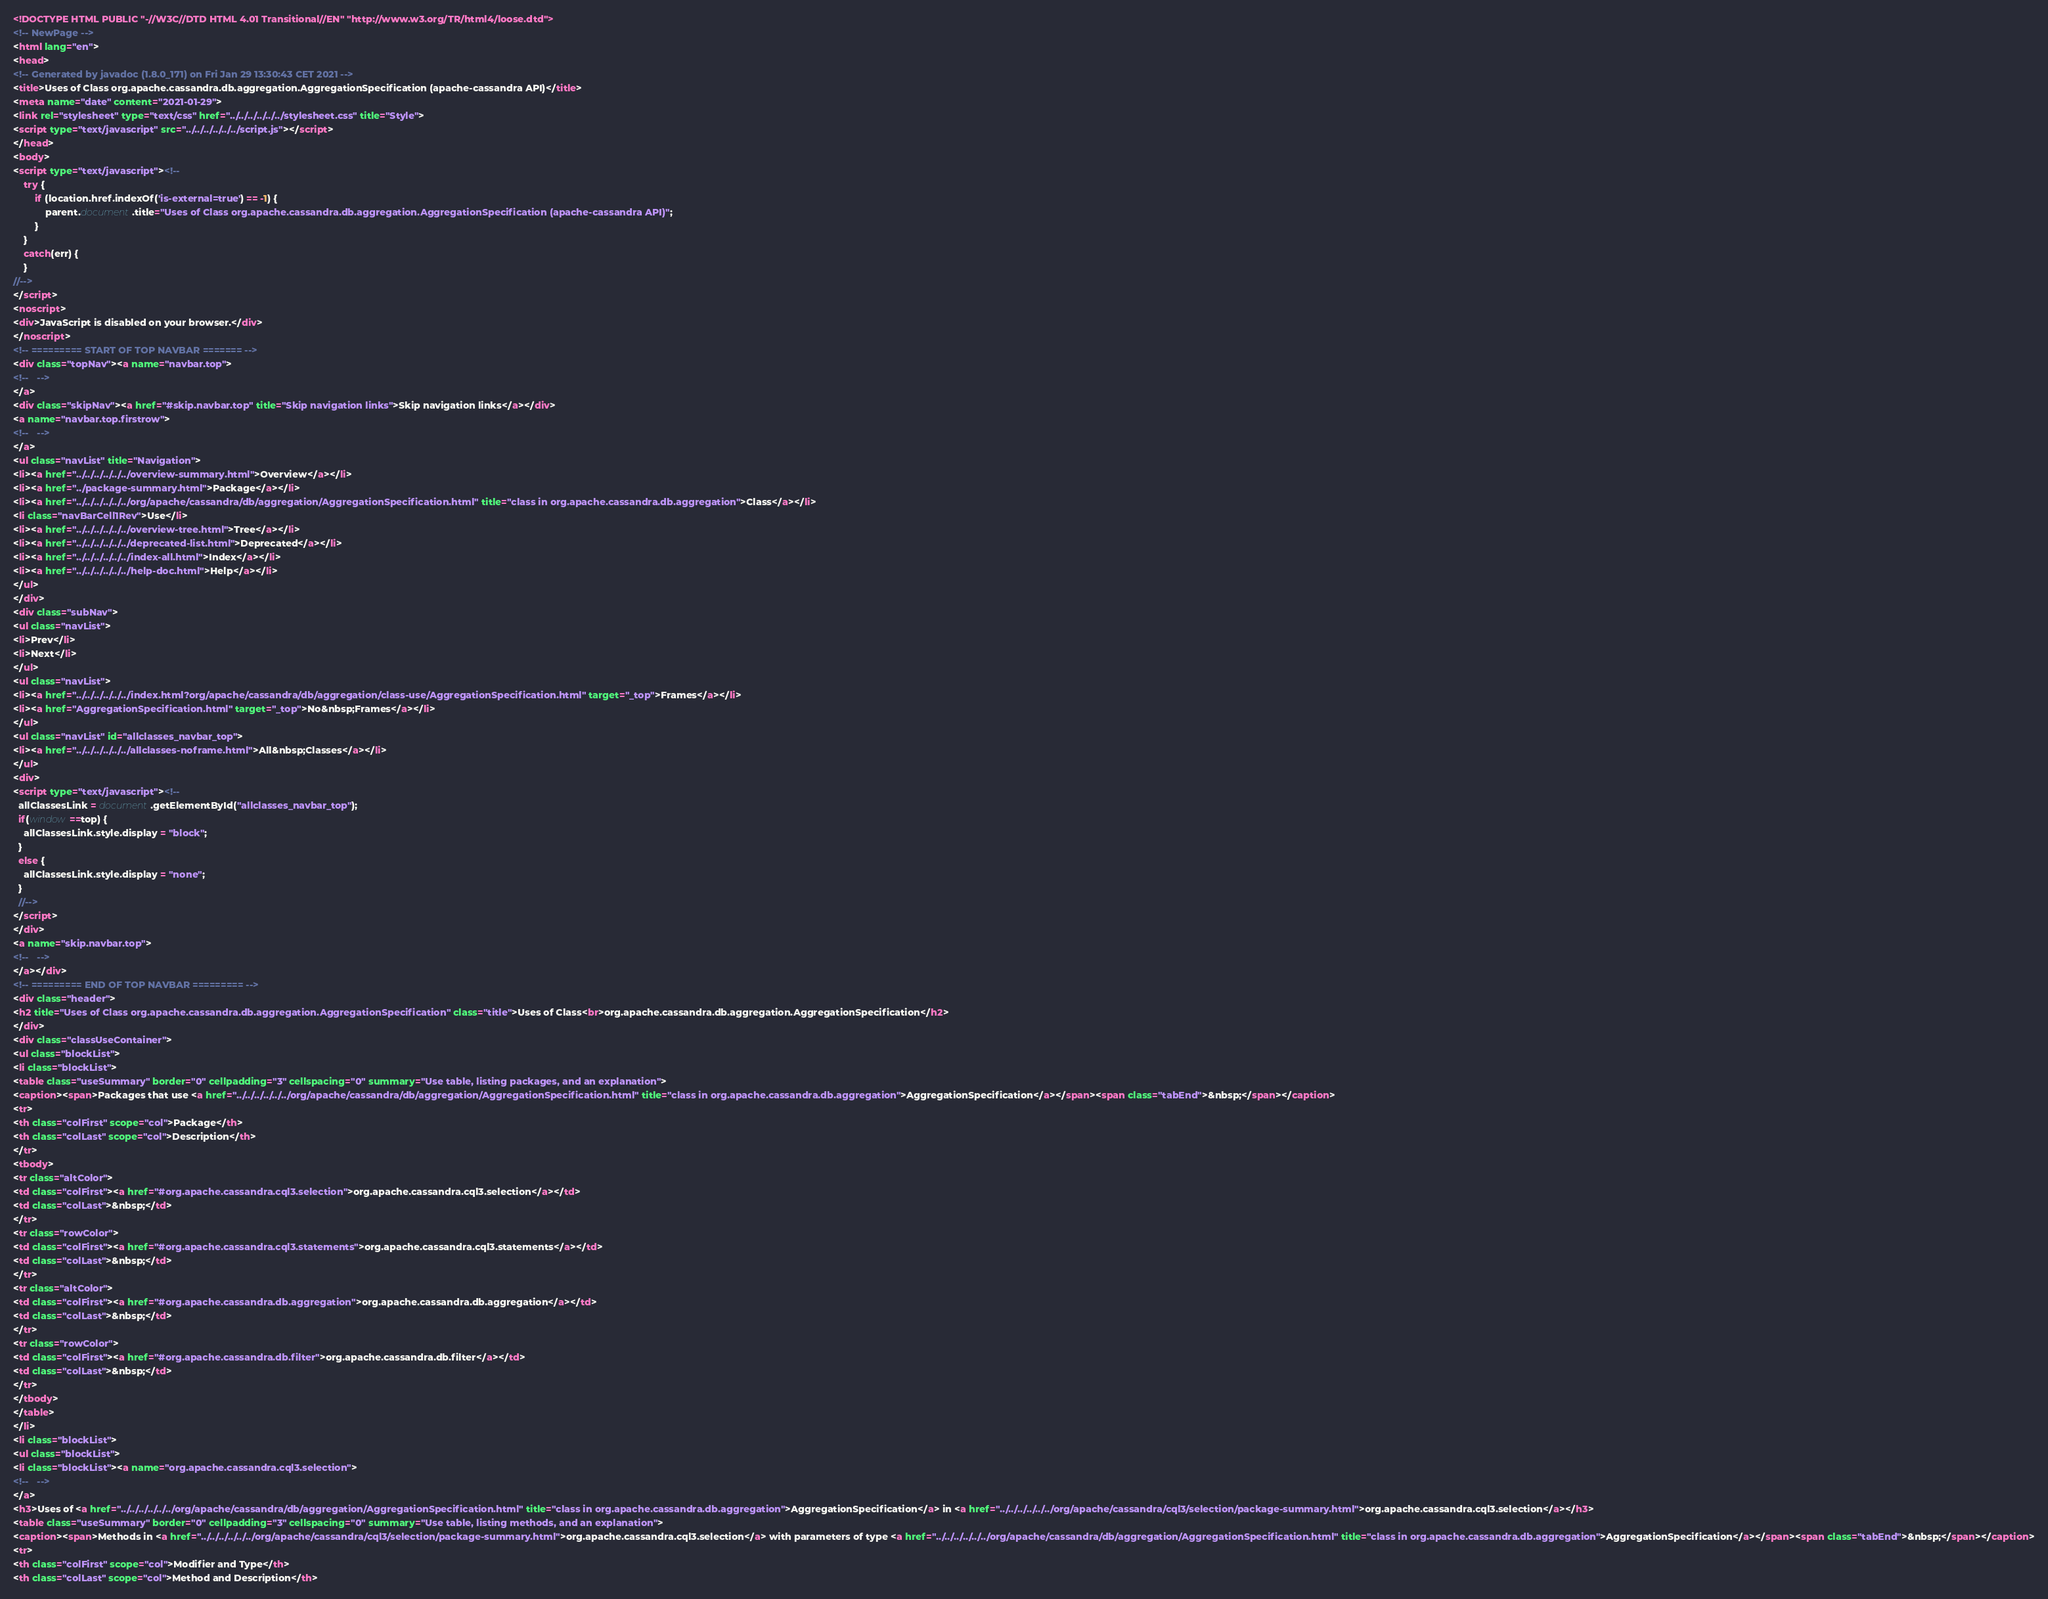Convert code to text. <code><loc_0><loc_0><loc_500><loc_500><_HTML_><!DOCTYPE HTML PUBLIC "-//W3C//DTD HTML 4.01 Transitional//EN" "http://www.w3.org/TR/html4/loose.dtd">
<!-- NewPage -->
<html lang="en">
<head>
<!-- Generated by javadoc (1.8.0_171) on Fri Jan 29 13:30:43 CET 2021 -->
<title>Uses of Class org.apache.cassandra.db.aggregation.AggregationSpecification (apache-cassandra API)</title>
<meta name="date" content="2021-01-29">
<link rel="stylesheet" type="text/css" href="../../../../../../stylesheet.css" title="Style">
<script type="text/javascript" src="../../../../../../script.js"></script>
</head>
<body>
<script type="text/javascript"><!--
    try {
        if (location.href.indexOf('is-external=true') == -1) {
            parent.document.title="Uses of Class org.apache.cassandra.db.aggregation.AggregationSpecification (apache-cassandra API)";
        }
    }
    catch(err) {
    }
//-->
</script>
<noscript>
<div>JavaScript is disabled on your browser.</div>
</noscript>
<!-- ========= START OF TOP NAVBAR ======= -->
<div class="topNav"><a name="navbar.top">
<!--   -->
</a>
<div class="skipNav"><a href="#skip.navbar.top" title="Skip navigation links">Skip navigation links</a></div>
<a name="navbar.top.firstrow">
<!--   -->
</a>
<ul class="navList" title="Navigation">
<li><a href="../../../../../../overview-summary.html">Overview</a></li>
<li><a href="../package-summary.html">Package</a></li>
<li><a href="../../../../../../org/apache/cassandra/db/aggregation/AggregationSpecification.html" title="class in org.apache.cassandra.db.aggregation">Class</a></li>
<li class="navBarCell1Rev">Use</li>
<li><a href="../../../../../../overview-tree.html">Tree</a></li>
<li><a href="../../../../../../deprecated-list.html">Deprecated</a></li>
<li><a href="../../../../../../index-all.html">Index</a></li>
<li><a href="../../../../../../help-doc.html">Help</a></li>
</ul>
</div>
<div class="subNav">
<ul class="navList">
<li>Prev</li>
<li>Next</li>
</ul>
<ul class="navList">
<li><a href="../../../../../../index.html?org/apache/cassandra/db/aggregation/class-use/AggregationSpecification.html" target="_top">Frames</a></li>
<li><a href="AggregationSpecification.html" target="_top">No&nbsp;Frames</a></li>
</ul>
<ul class="navList" id="allclasses_navbar_top">
<li><a href="../../../../../../allclasses-noframe.html">All&nbsp;Classes</a></li>
</ul>
<div>
<script type="text/javascript"><!--
  allClassesLink = document.getElementById("allclasses_navbar_top");
  if(window==top) {
    allClassesLink.style.display = "block";
  }
  else {
    allClassesLink.style.display = "none";
  }
  //-->
</script>
</div>
<a name="skip.navbar.top">
<!--   -->
</a></div>
<!-- ========= END OF TOP NAVBAR ========= -->
<div class="header">
<h2 title="Uses of Class org.apache.cassandra.db.aggregation.AggregationSpecification" class="title">Uses of Class<br>org.apache.cassandra.db.aggregation.AggregationSpecification</h2>
</div>
<div class="classUseContainer">
<ul class="blockList">
<li class="blockList">
<table class="useSummary" border="0" cellpadding="3" cellspacing="0" summary="Use table, listing packages, and an explanation">
<caption><span>Packages that use <a href="../../../../../../org/apache/cassandra/db/aggregation/AggregationSpecification.html" title="class in org.apache.cassandra.db.aggregation">AggregationSpecification</a></span><span class="tabEnd">&nbsp;</span></caption>
<tr>
<th class="colFirst" scope="col">Package</th>
<th class="colLast" scope="col">Description</th>
</tr>
<tbody>
<tr class="altColor">
<td class="colFirst"><a href="#org.apache.cassandra.cql3.selection">org.apache.cassandra.cql3.selection</a></td>
<td class="colLast">&nbsp;</td>
</tr>
<tr class="rowColor">
<td class="colFirst"><a href="#org.apache.cassandra.cql3.statements">org.apache.cassandra.cql3.statements</a></td>
<td class="colLast">&nbsp;</td>
</tr>
<tr class="altColor">
<td class="colFirst"><a href="#org.apache.cassandra.db.aggregation">org.apache.cassandra.db.aggregation</a></td>
<td class="colLast">&nbsp;</td>
</tr>
<tr class="rowColor">
<td class="colFirst"><a href="#org.apache.cassandra.db.filter">org.apache.cassandra.db.filter</a></td>
<td class="colLast">&nbsp;</td>
</tr>
</tbody>
</table>
</li>
<li class="blockList">
<ul class="blockList">
<li class="blockList"><a name="org.apache.cassandra.cql3.selection">
<!--   -->
</a>
<h3>Uses of <a href="../../../../../../org/apache/cassandra/db/aggregation/AggregationSpecification.html" title="class in org.apache.cassandra.db.aggregation">AggregationSpecification</a> in <a href="../../../../../../org/apache/cassandra/cql3/selection/package-summary.html">org.apache.cassandra.cql3.selection</a></h3>
<table class="useSummary" border="0" cellpadding="3" cellspacing="0" summary="Use table, listing methods, and an explanation">
<caption><span>Methods in <a href="../../../../../../org/apache/cassandra/cql3/selection/package-summary.html">org.apache.cassandra.cql3.selection</a> with parameters of type <a href="../../../../../../org/apache/cassandra/db/aggregation/AggregationSpecification.html" title="class in org.apache.cassandra.db.aggregation">AggregationSpecification</a></span><span class="tabEnd">&nbsp;</span></caption>
<tr>
<th class="colFirst" scope="col">Modifier and Type</th>
<th class="colLast" scope="col">Method and Description</th></code> 